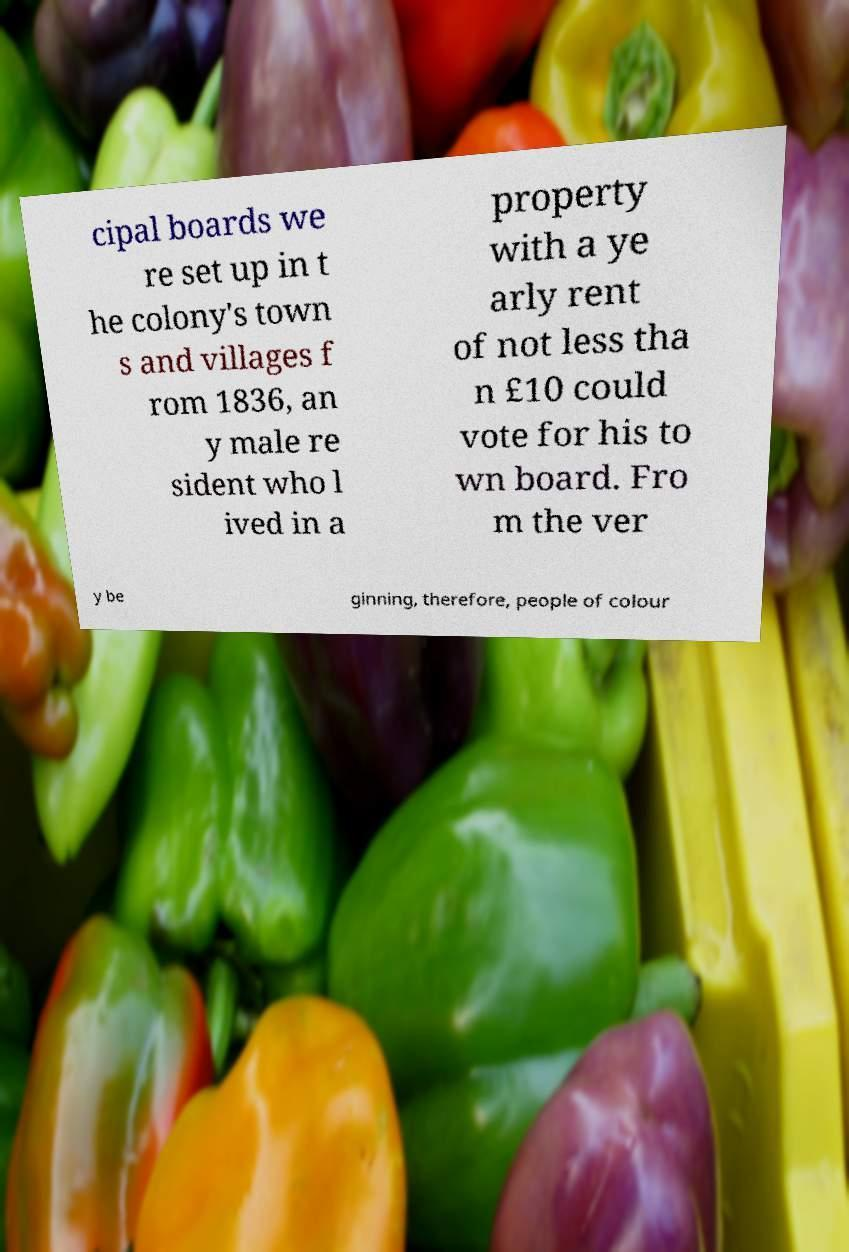Could you extract and type out the text from this image? cipal boards we re set up in t he colony's town s and villages f rom 1836, an y male re sident who l ived in a property with a ye arly rent of not less tha n £10 could vote for his to wn board. Fro m the ver y be ginning, therefore, people of colour 